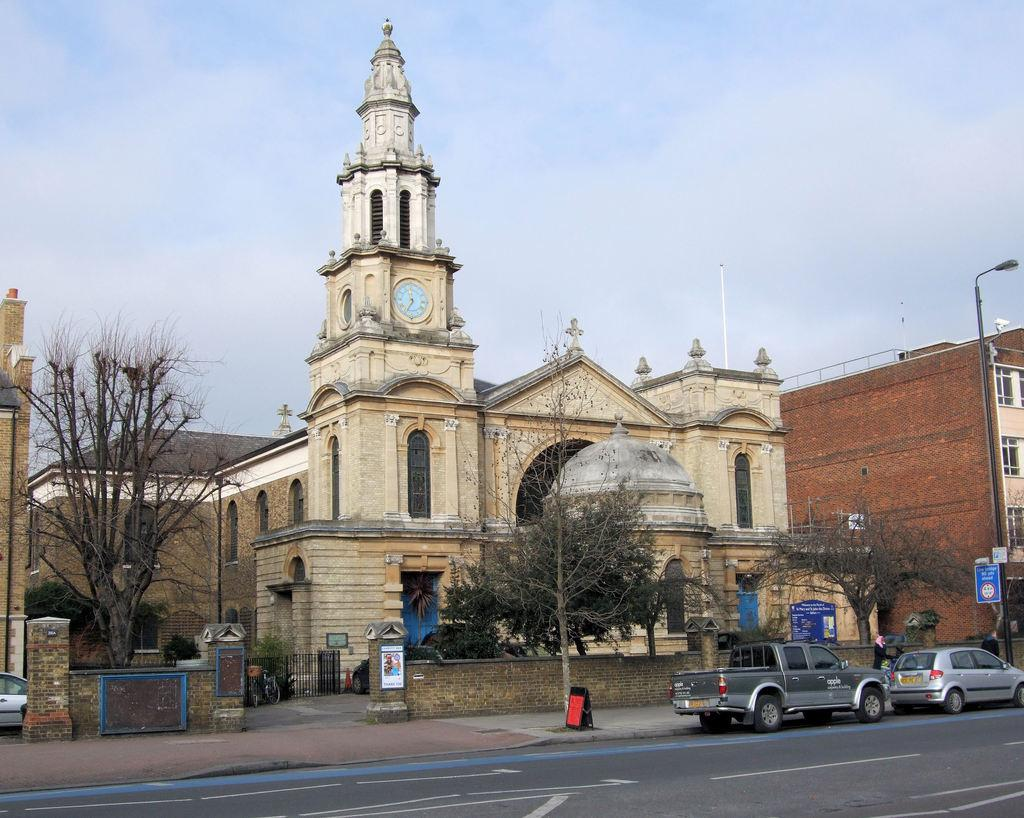What type of structures can be seen in the image? There are buildings in the image. What other natural elements are present in the image? There are trees in the image. What specific feature can be identified among the buildings? There is a clock tower in the image. What objects are related to food preparation in the image? There are grills in the image. What type of signage is present in the image? There are boards in the image. What is moving along the road in the image? There are vehicles on the road in the image. What vertical structures can be seen in the image? There are poles in the image. What is visible at the top of the image? The sky is visible at the top of the image. How many tickets are visible on the poles in the image? There are no tickets present on the poles in the image. What type of wave can be seen crashing on the shore in the image? There is no shore or wave present in the image. What letters are written on the boards in the image? The provided facts do not mention any specific letters on the boards, so we cannot determine what letters are written on them. 